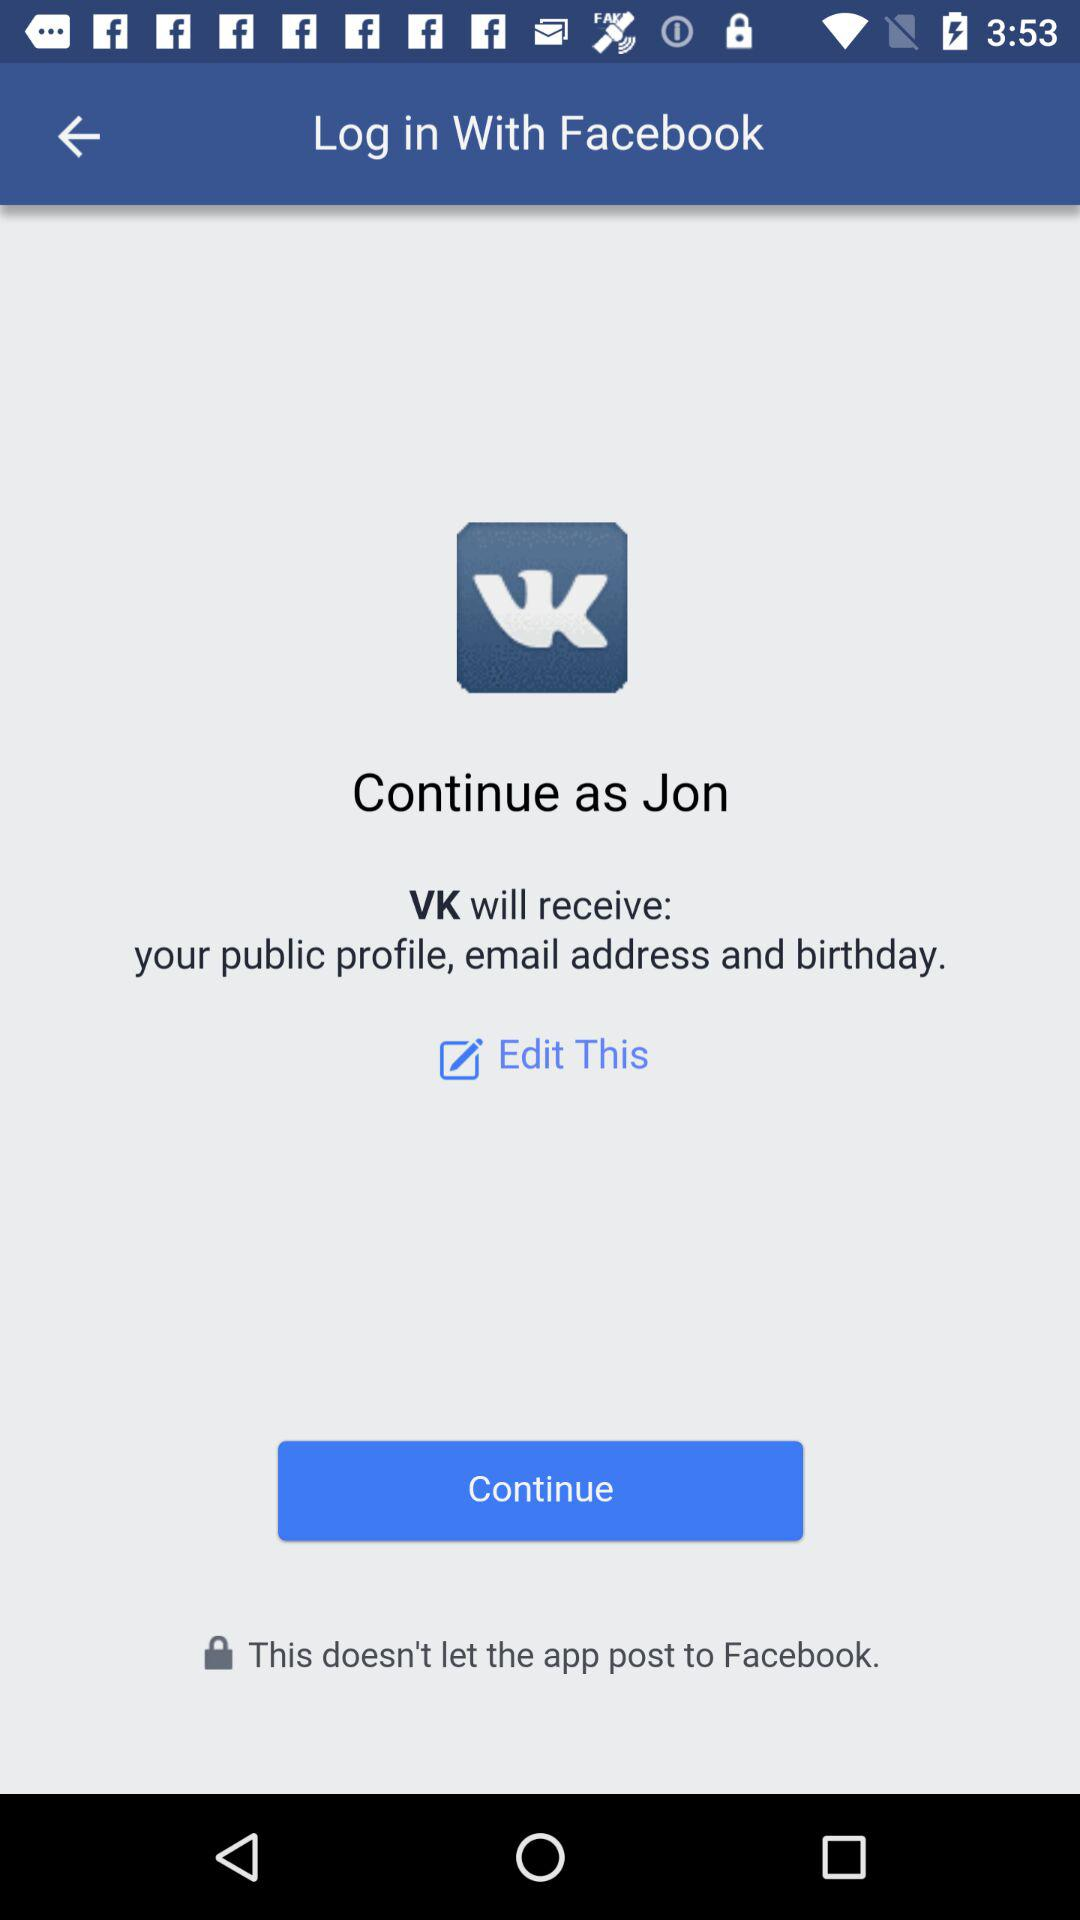What application is asking for the permission? The application is "VK". 